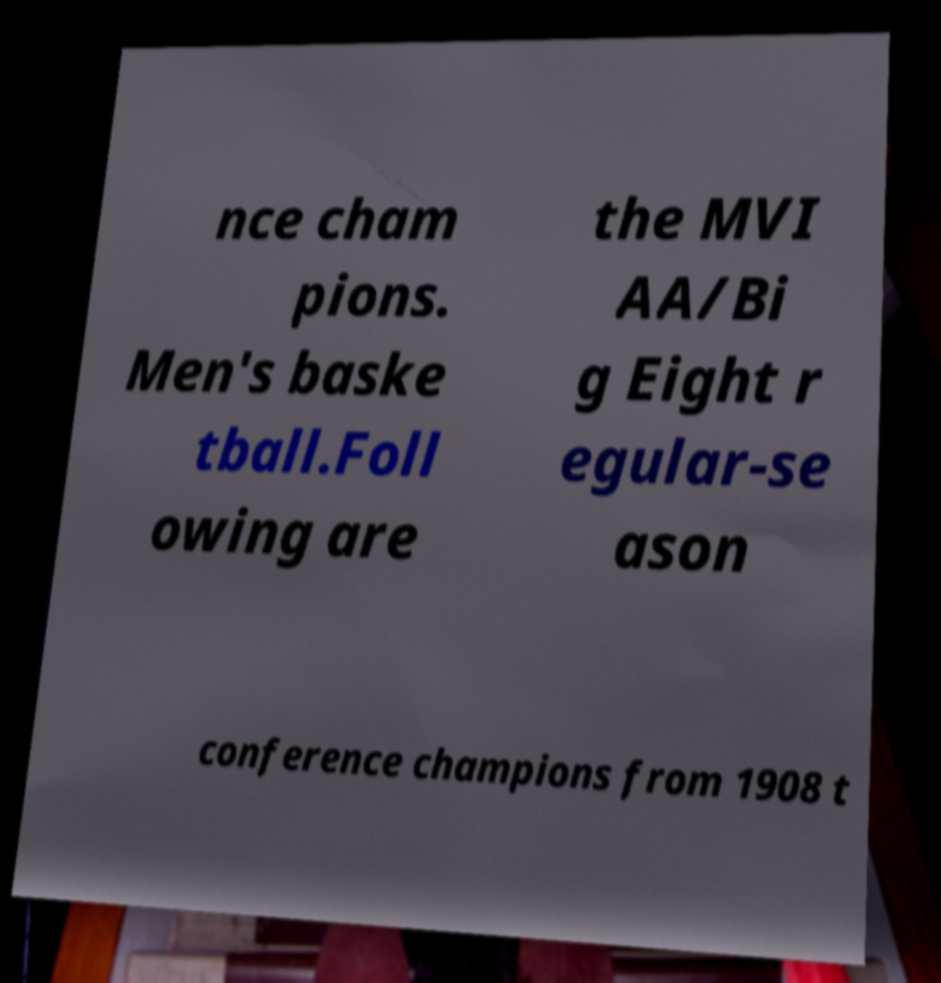Can you read and provide the text displayed in the image?This photo seems to have some interesting text. Can you extract and type it out for me? nce cham pions. Men's baske tball.Foll owing are the MVI AA/Bi g Eight r egular-se ason conference champions from 1908 t 